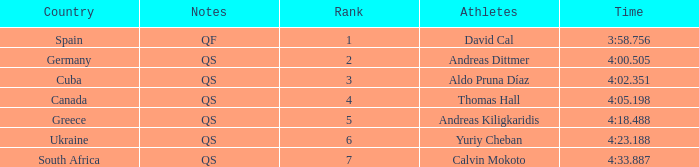What is Andreas Kiligkaridis rank? 5.0. 